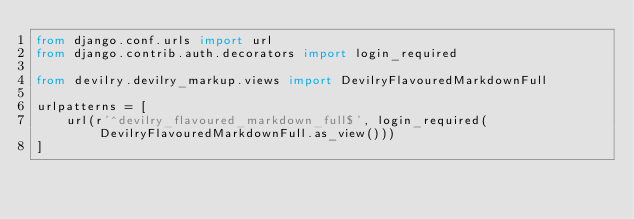Convert code to text. <code><loc_0><loc_0><loc_500><loc_500><_Python_>from django.conf.urls import url
from django.contrib.auth.decorators import login_required

from devilry.devilry_markup.views import DevilryFlavouredMarkdownFull

urlpatterns = [
    url(r'^devilry_flavoured_markdown_full$', login_required(DevilryFlavouredMarkdownFull.as_view()))
]
</code> 